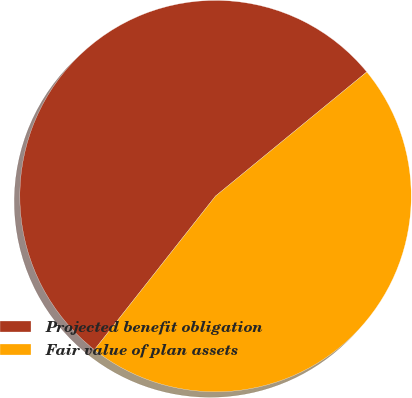Convert chart to OTSL. <chart><loc_0><loc_0><loc_500><loc_500><pie_chart><fcel>Projected benefit obligation<fcel>Fair value of plan assets<nl><fcel>53.44%<fcel>46.56%<nl></chart> 